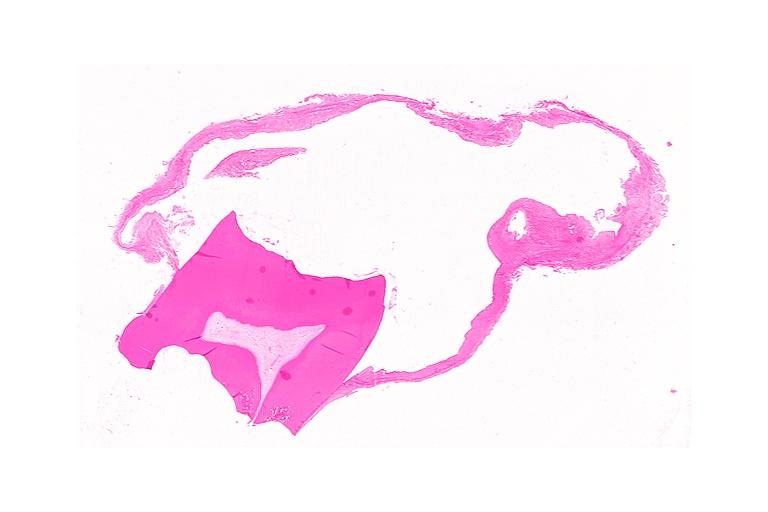where is this?
Answer the question using a single word or phrase. Oral 